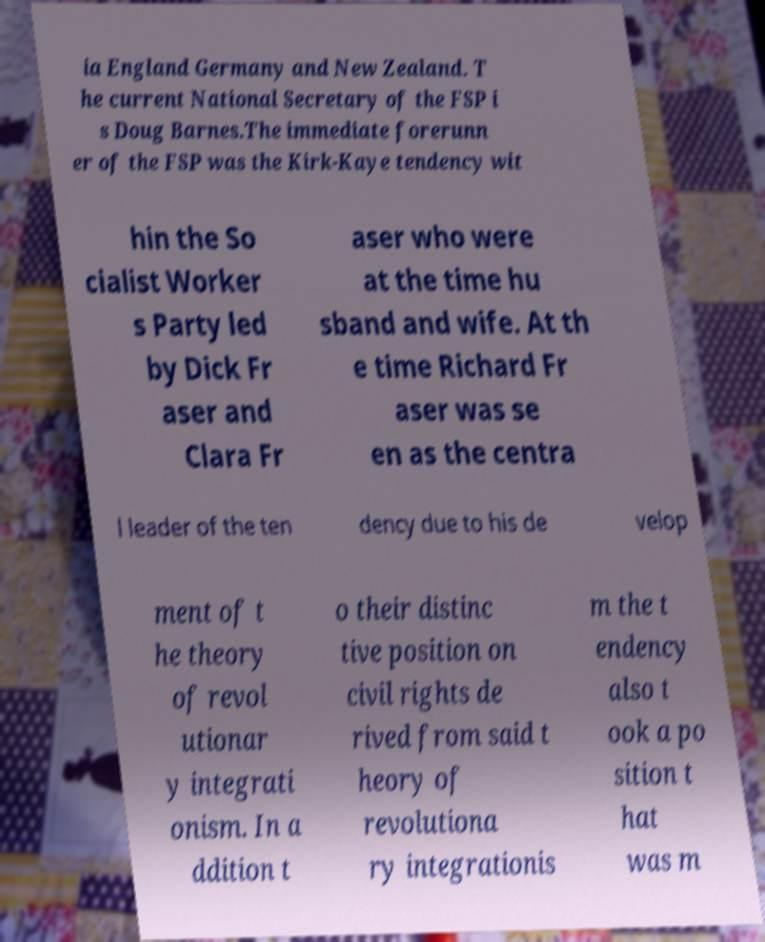There's text embedded in this image that I need extracted. Can you transcribe it verbatim? ia England Germany and New Zealand. T he current National Secretary of the FSP i s Doug Barnes.The immediate forerunn er of the FSP was the Kirk-Kaye tendency wit hin the So cialist Worker s Party led by Dick Fr aser and Clara Fr aser who were at the time hu sband and wife. At th e time Richard Fr aser was se en as the centra l leader of the ten dency due to his de velop ment of t he theory of revol utionar y integrati onism. In a ddition t o their distinc tive position on civil rights de rived from said t heory of revolutiona ry integrationis m the t endency also t ook a po sition t hat was m 